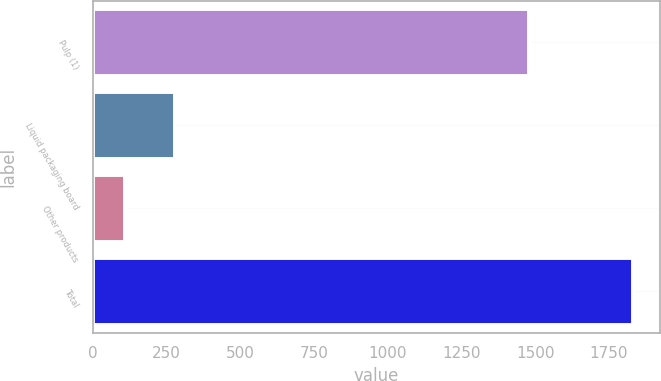<chart> <loc_0><loc_0><loc_500><loc_500><bar_chart><fcel>Pulp (1)<fcel>Liquid packaging board<fcel>Other products<fcel>Total<nl><fcel>1478<fcel>279.5<fcel>107<fcel>1832<nl></chart> 